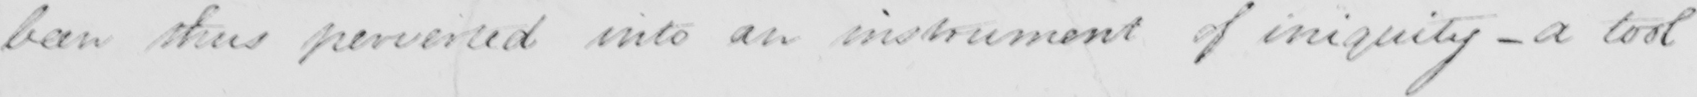Please transcribe the handwritten text in this image. been thus perverted into an instrument of iniquity - a tool 